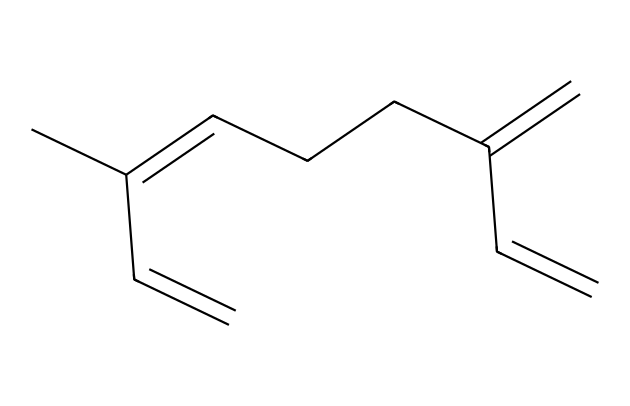What is the molecular formula of this compound? By analyzing the structure represented by the SMILES, we count the carbon and hydrogen atoms. The structure indicates there are 10 Carbon (C) atoms and 16 Hydrogen (H) atoms. Therefore, the molecular formula translates to C10H16.
Answer: C10H16 How many double bonds are present in myrcene? Examining the structure derived from the SMILES, we can visualize and count the double bonds which are represented by the "=" signs. There are three double bonds in the structure of myrcene.
Answer: 3 What type of compound is myrcene? Based on the structural characteristics shown in the SMILES representation, which indicates it's a hydrocarbon with multiple double bonds, myrcene is classified as a terpene.
Answer: terpene How many rings are in the myrcene structure? Upon reviewing the chemical structure derived from the SMILES, we can confirm that myrcene is a linear compound without any rings present. Therefore, the count is zero.
Answer: 0 What is the main functional group in myrcene? By analyzing the chemical structure, we see that there are multiple double bonds type (alkene functionality). However, since this compound does not show any other specific functional group (like alcohol or carbonyl), the primary characteristic is alkenes due to the presence of multiple C=C bonds.
Answer: alkene How does the structure of myrcene affect its aroma? The unique branching and presence of multiple double bonds in myrcene contribute to its fragrant citrus and earthy notes, typical of many terpenes. Thus, the structure directly plays a role in its aromatic profile.
Answer: aromatic profile 